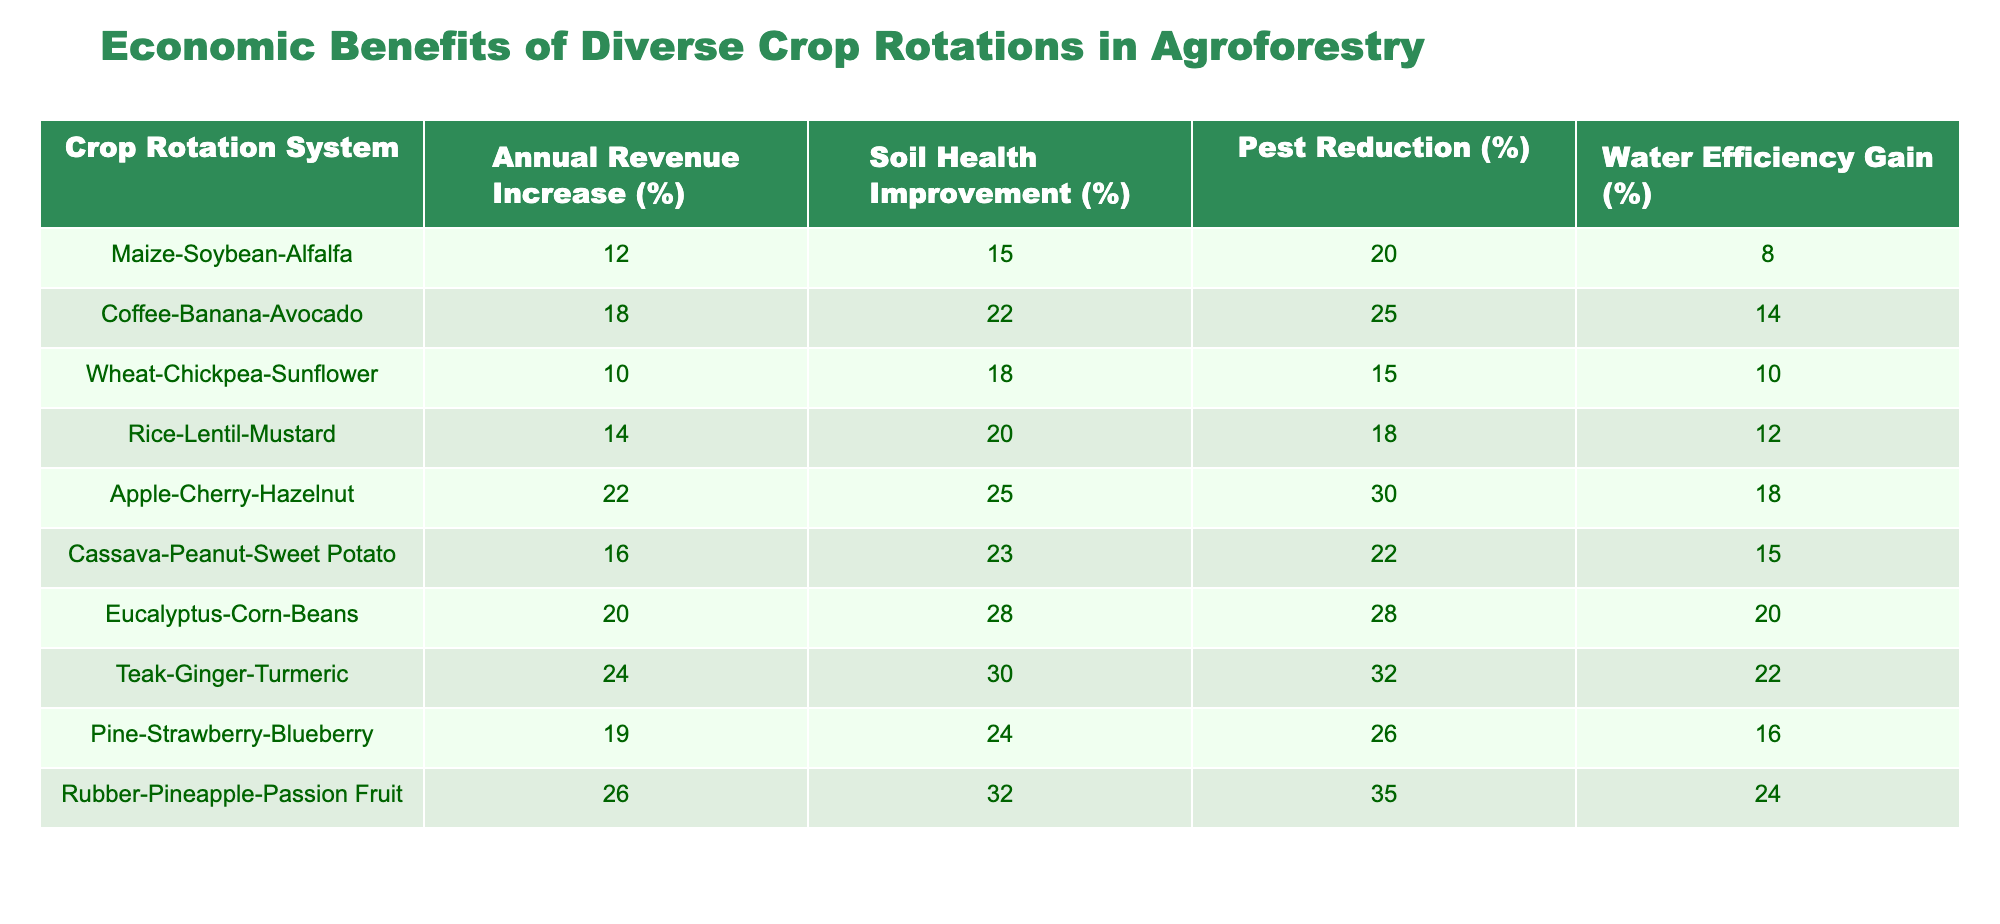What is the annual revenue increase percentage for the Cassava-Peanut-Sweet Potato rotation? The table shows the annual revenue increase for the Cassava-Peanut-Sweet Potato crop rotation system as 16%.
Answer: 16% Which crop rotation has the highest soil health improvement percentage? By examining the soil health improvement column, the Teak-Ginger-Turmeric rotation shows the highest percentage at 30%.
Answer: Teak-Ginger-Turmeric What is the average pest reduction percentage across all crop rotation systems? The total pest reduction percentages are calculated as follows: (20 + 25 + 15 + 18 + 30 + 22 + 28 + 32 + 26 + 35) = 301. There are 10 systems, so the average is 301/10 = 30.1%.
Answer: 30.1% Is the annual revenue increase for the Apple-Cherry-Hazelnut rotation greater than 20%? According to the table, the annual revenue increase for the Apple-Cherry-Hazelnut crop rotation is 22%, which is indeed greater than 20%.
Answer: Yes Which crop rotation system results in the highest combined gain in water efficiency and soil health improvement? The water efficiency gains and soil health improvements are summed for each rotation. The Teak-Ginger-Turmeric rotation has a water efficiency gain of 22% and soil health improvement of 30%, totaling 52%. Comparing all systems, Teak-Ginger-Turmeric has the highest combined total.
Answer: Teak-Ginger-Turmeric 